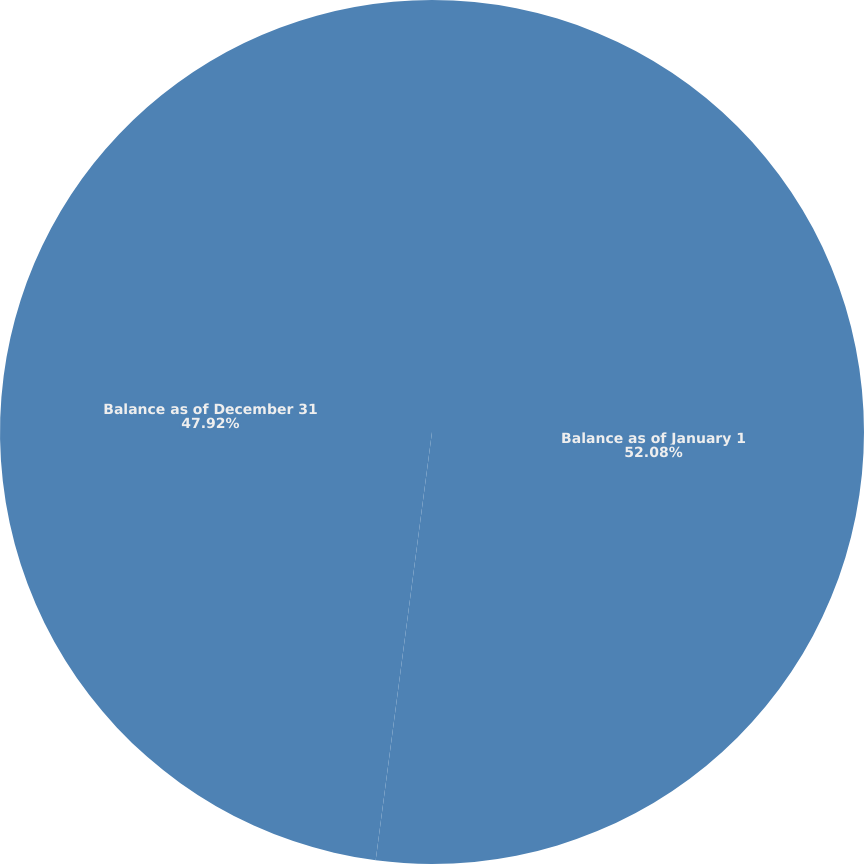Convert chart to OTSL. <chart><loc_0><loc_0><loc_500><loc_500><pie_chart><fcel>Balance as of January 1<fcel>Balance as of December 31<nl><fcel>52.08%<fcel>47.92%<nl></chart> 